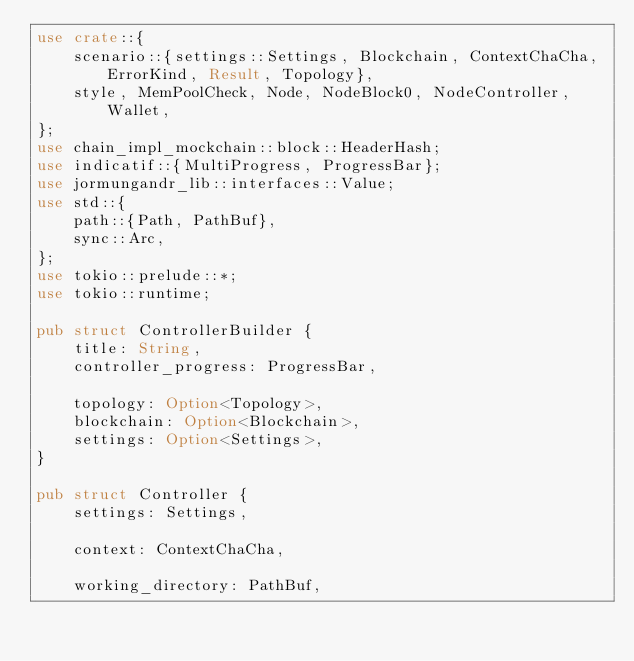<code> <loc_0><loc_0><loc_500><loc_500><_Rust_>use crate::{
    scenario::{settings::Settings, Blockchain, ContextChaCha, ErrorKind, Result, Topology},
    style, MemPoolCheck, Node, NodeBlock0, NodeController, Wallet,
};
use chain_impl_mockchain::block::HeaderHash;
use indicatif::{MultiProgress, ProgressBar};
use jormungandr_lib::interfaces::Value;
use std::{
    path::{Path, PathBuf},
    sync::Arc,
};
use tokio::prelude::*;
use tokio::runtime;

pub struct ControllerBuilder {
    title: String,
    controller_progress: ProgressBar,

    topology: Option<Topology>,
    blockchain: Option<Blockchain>,
    settings: Option<Settings>,
}

pub struct Controller {
    settings: Settings,

    context: ContextChaCha,

    working_directory: PathBuf,
</code> 